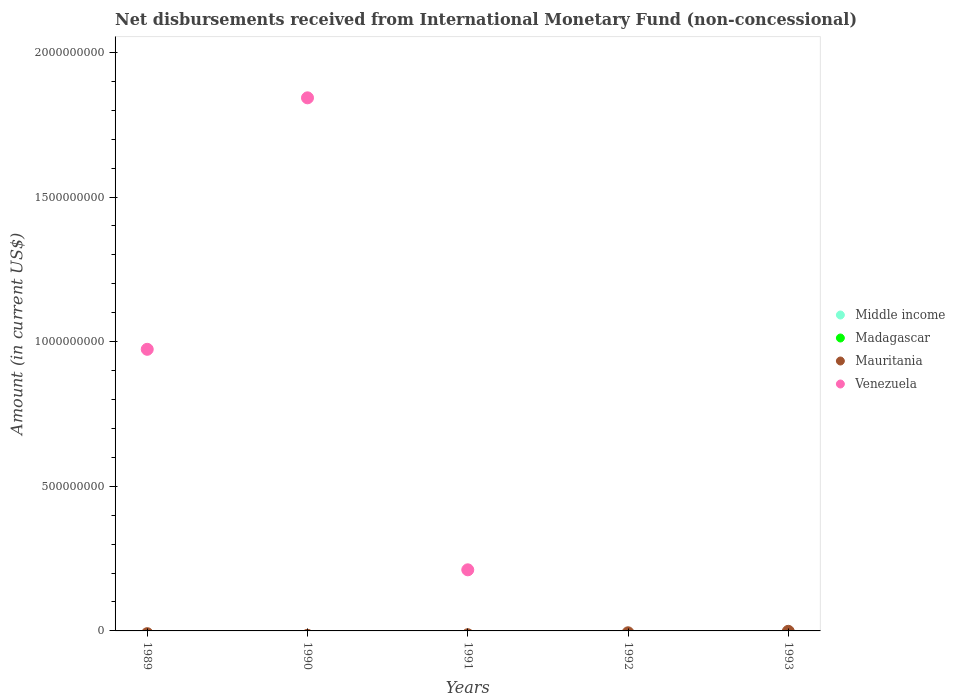Across all years, what is the maximum amount of disbursements received from International Monetary Fund in Venezuela?
Ensure brevity in your answer.  1.84e+09. What is the difference between the amount of disbursements received from International Monetary Fund in Mauritania in 1991 and the amount of disbursements received from International Monetary Fund in Venezuela in 1990?
Your response must be concise. -1.84e+09. What is the average amount of disbursements received from International Monetary Fund in Venezuela per year?
Make the answer very short. 6.06e+08. What is the difference between the highest and the second highest amount of disbursements received from International Monetary Fund in Venezuela?
Give a very brief answer. 8.69e+08. In how many years, is the amount of disbursements received from International Monetary Fund in Venezuela greater than the average amount of disbursements received from International Monetary Fund in Venezuela taken over all years?
Provide a succinct answer. 2. Is it the case that in every year, the sum of the amount of disbursements received from International Monetary Fund in Middle income and amount of disbursements received from International Monetary Fund in Venezuela  is greater than the sum of amount of disbursements received from International Monetary Fund in Mauritania and amount of disbursements received from International Monetary Fund in Madagascar?
Provide a succinct answer. No. Is it the case that in every year, the sum of the amount of disbursements received from International Monetary Fund in Madagascar and amount of disbursements received from International Monetary Fund in Middle income  is greater than the amount of disbursements received from International Monetary Fund in Venezuela?
Offer a terse response. No. How many dotlines are there?
Your response must be concise. 1. How many years are there in the graph?
Your response must be concise. 5. Where does the legend appear in the graph?
Provide a short and direct response. Center right. What is the title of the graph?
Provide a short and direct response. Net disbursements received from International Monetary Fund (non-concessional). What is the label or title of the X-axis?
Your response must be concise. Years. What is the Amount (in current US$) in Middle income in 1989?
Ensure brevity in your answer.  0. What is the Amount (in current US$) of Madagascar in 1989?
Give a very brief answer. 0. What is the Amount (in current US$) in Venezuela in 1989?
Provide a short and direct response. 9.74e+08. What is the Amount (in current US$) in Mauritania in 1990?
Your answer should be compact. 0. What is the Amount (in current US$) in Venezuela in 1990?
Offer a terse response. 1.84e+09. What is the Amount (in current US$) in Middle income in 1991?
Provide a succinct answer. 0. What is the Amount (in current US$) of Mauritania in 1991?
Your answer should be compact. 0. What is the Amount (in current US$) in Venezuela in 1991?
Keep it short and to the point. 2.11e+08. What is the Amount (in current US$) of Madagascar in 1992?
Ensure brevity in your answer.  0. What is the Amount (in current US$) in Venezuela in 1992?
Make the answer very short. 0. What is the Amount (in current US$) of Mauritania in 1993?
Ensure brevity in your answer.  0. What is the Amount (in current US$) in Venezuela in 1993?
Your answer should be compact. 0. Across all years, what is the maximum Amount (in current US$) in Venezuela?
Your answer should be compact. 1.84e+09. Across all years, what is the minimum Amount (in current US$) in Venezuela?
Make the answer very short. 0. What is the total Amount (in current US$) of Middle income in the graph?
Keep it short and to the point. 0. What is the total Amount (in current US$) in Madagascar in the graph?
Offer a very short reply. 0. What is the total Amount (in current US$) in Venezuela in the graph?
Your response must be concise. 3.03e+09. What is the difference between the Amount (in current US$) in Venezuela in 1989 and that in 1990?
Give a very brief answer. -8.69e+08. What is the difference between the Amount (in current US$) in Venezuela in 1989 and that in 1991?
Offer a very short reply. 7.62e+08. What is the difference between the Amount (in current US$) of Venezuela in 1990 and that in 1991?
Your response must be concise. 1.63e+09. What is the average Amount (in current US$) of Venezuela per year?
Your answer should be very brief. 6.06e+08. What is the ratio of the Amount (in current US$) in Venezuela in 1989 to that in 1990?
Your answer should be compact. 0.53. What is the ratio of the Amount (in current US$) of Venezuela in 1989 to that in 1991?
Your answer should be compact. 4.61. What is the ratio of the Amount (in current US$) in Venezuela in 1990 to that in 1991?
Make the answer very short. 8.72. What is the difference between the highest and the second highest Amount (in current US$) of Venezuela?
Make the answer very short. 8.69e+08. What is the difference between the highest and the lowest Amount (in current US$) in Venezuela?
Your answer should be very brief. 1.84e+09. 